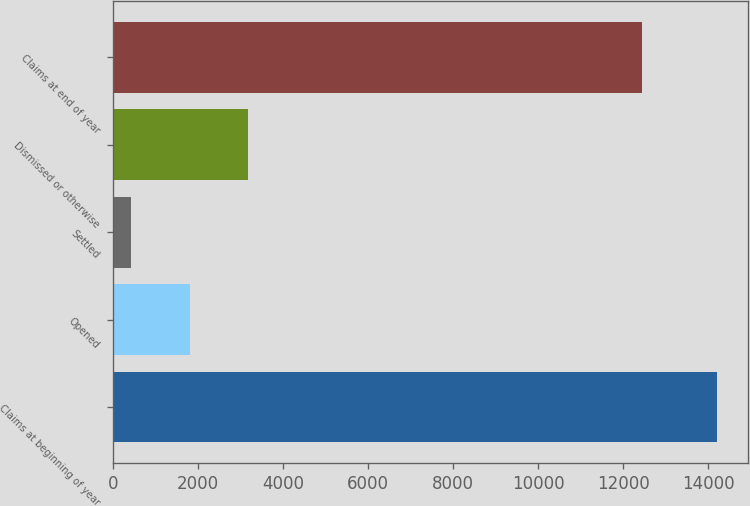<chart> <loc_0><loc_0><loc_500><loc_500><bar_chart><fcel>Claims at beginning of year<fcel>Opened<fcel>Settled<fcel>Dismissed or otherwise<fcel>Claims at end of year<nl><fcel>14215<fcel>1804.9<fcel>426<fcel>3183.8<fcel>12454<nl></chart> 